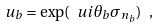<formula> <loc_0><loc_0><loc_500><loc_500>u _ { b } = \exp ( \ u i \theta _ { b } \sigma _ { n _ { b } } ) \ ,</formula> 